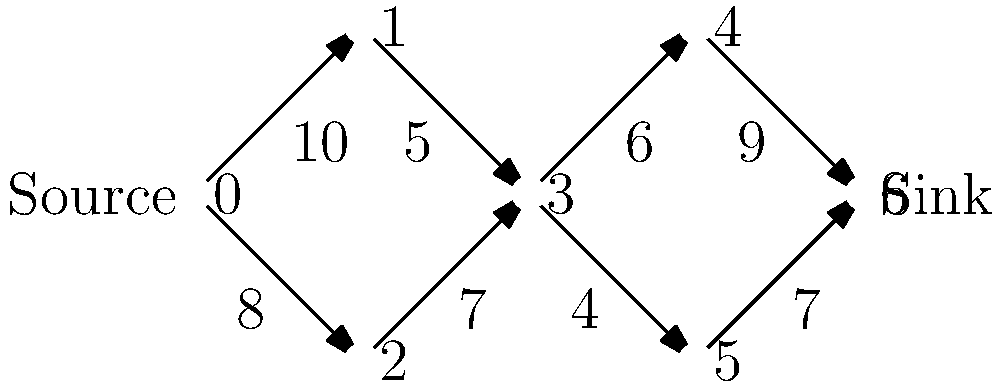In a smart grid system modeled as a flow network, the maximum flow represents the optimal energy distribution. Given the network above, where edge weights represent energy capacity in megawatts, what is the maximum flow from the source (node 0) to the sink (node 6)? How does this relate to the system's overall energy efficiency? To solve this problem, we'll use the Ford-Fulkerson algorithm to find the maximum flow:

1) Initialize flow to 0.

2) Find augmenting paths from source to sink:
   a) Path 0-1-3-4-6: min capacity = 5, Flow = 5
   b) Path 0-2-3-5-6: min capacity = 7, Flow = 5 + 7 = 12
   c) Path 0-1-3-5-6: min capacity = 1, Flow = 12 + 1 = 13
   d) No more augmenting paths

3) The maximum flow is 13 MW.

This result relates to energy efficiency in several ways:

1) It represents the maximum amount of energy that can be transmitted from the source (e.g., a renewable energy plant) to the sink (e.g., a distribution center) given the current infrastructure.

2) It identifies potential bottlenecks in the system. Here, the paths through nodes 3 and 4 or 5 are limiting factors.

3) It can guide infrastructure improvements: increasing capacity on edges (3,4) and (3,5) could potentially increase overall flow.

4) In a smart grid, this algorithm could be used dynamically to optimize energy routing based on real-time demand and supply fluctuations, thereby improving overall system efficiency.
Answer: 13 MW; identifies maximum energy transmission capacity and system bottlenecks 